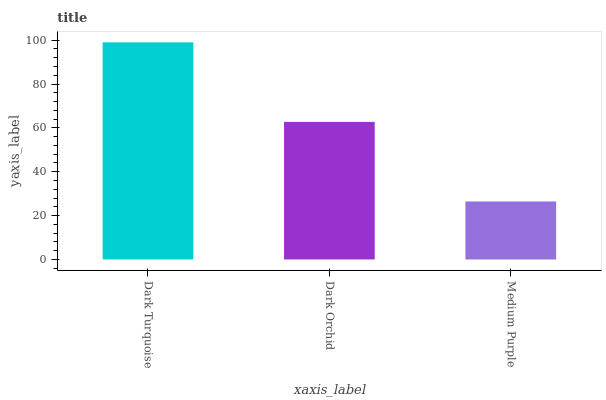Is Dark Orchid the minimum?
Answer yes or no. No. Is Dark Orchid the maximum?
Answer yes or no. No. Is Dark Turquoise greater than Dark Orchid?
Answer yes or no. Yes. Is Dark Orchid less than Dark Turquoise?
Answer yes or no. Yes. Is Dark Orchid greater than Dark Turquoise?
Answer yes or no. No. Is Dark Turquoise less than Dark Orchid?
Answer yes or no. No. Is Dark Orchid the high median?
Answer yes or no. Yes. Is Dark Orchid the low median?
Answer yes or no. Yes. Is Medium Purple the high median?
Answer yes or no. No. Is Dark Turquoise the low median?
Answer yes or no. No. 